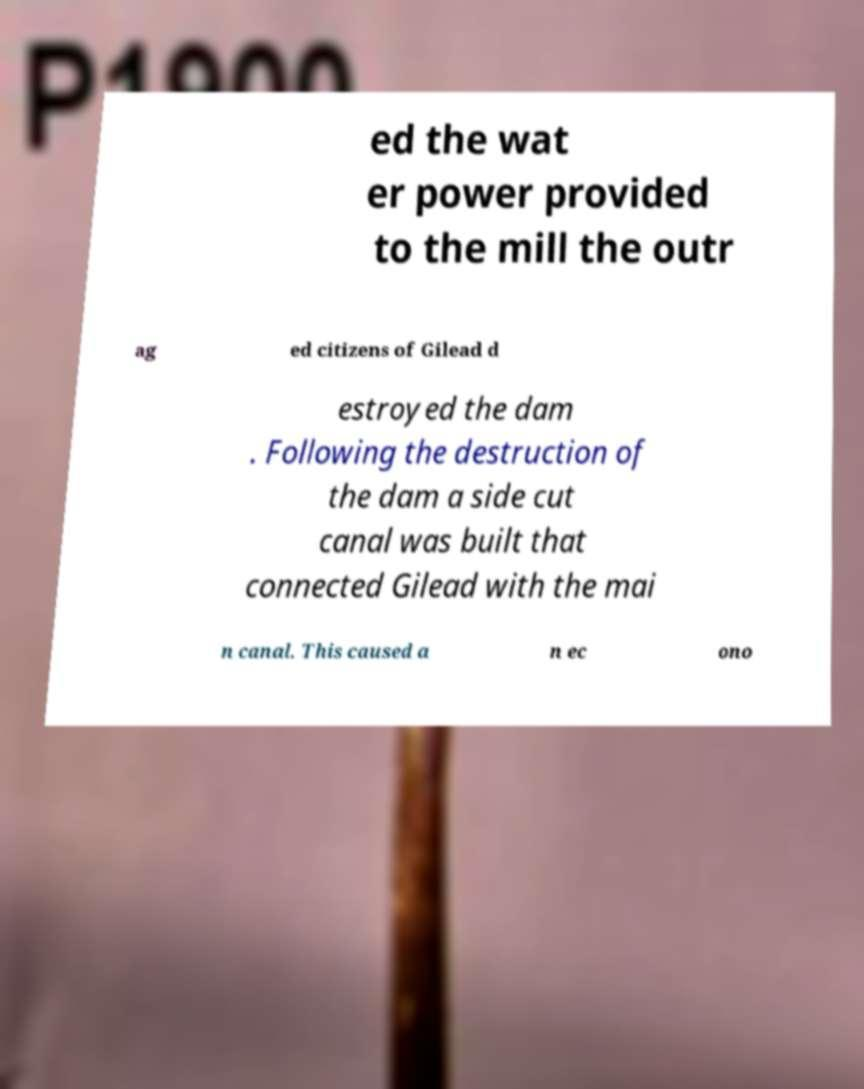For documentation purposes, I need the text within this image transcribed. Could you provide that? ed the wat er power provided to the mill the outr ag ed citizens of Gilead d estroyed the dam . Following the destruction of the dam a side cut canal was built that connected Gilead with the mai n canal. This caused a n ec ono 